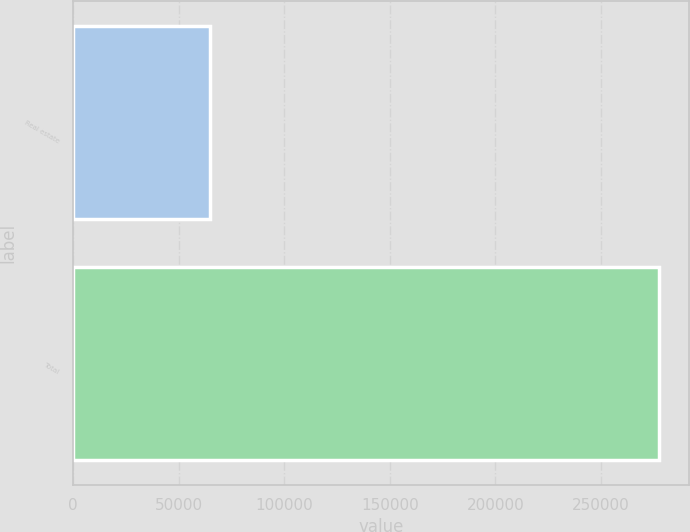<chart> <loc_0><loc_0><loc_500><loc_500><bar_chart><fcel>Real estate<fcel>Total<nl><fcel>64597<fcel>277638<nl></chart> 